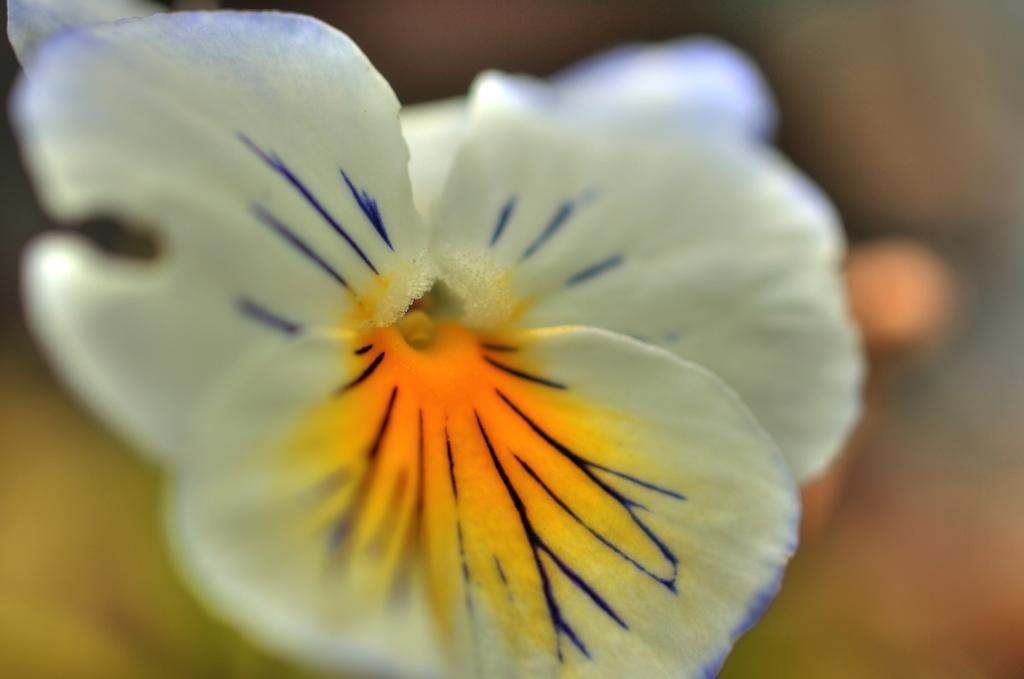What is the main subject of the image? There is a flower in the image. Is there a payment system visible in the image? There is no payment system present in the image; it features a flower. Is there a crown on the flower in the image? There is no crown visible on the flower in the image. 